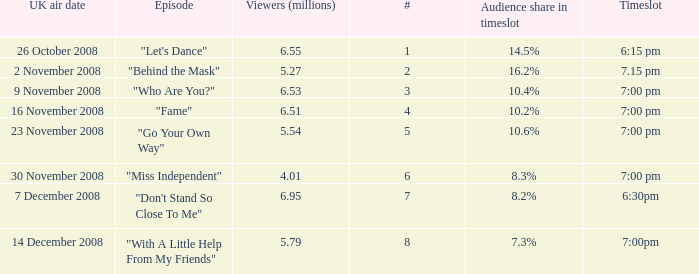Name the total number of timeslot for number 1 1.0. 